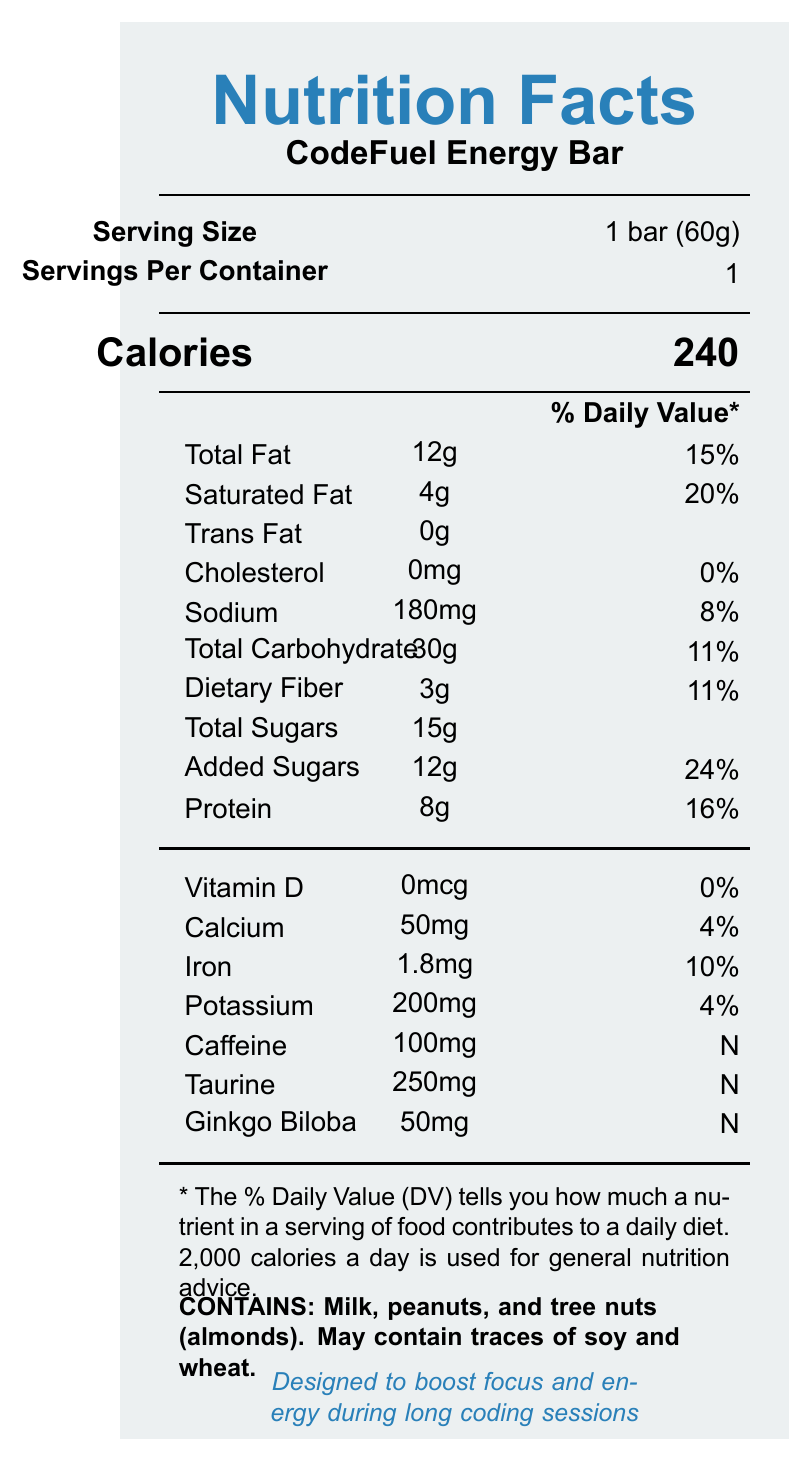What is the serving size of the CodeFuel Energy Bar? The serving size is listed in the Serving Info section and states "1 bar (60g)".
Answer: 1 bar (60g) How many calories are in one serving of the CodeFuel Energy Bar? The Calories section indicates that there are 240 calories per serving.
Answer: 240 What is the amount of total fat in the CodeFuel Energy Bar? The Nutrient table lists the Total Fat amount as 12g.
Answer: 12g How much protein does the CodeFuel Energy Bar contain? The Nutrient table shows that the CodeFuel Energy Bar contains 8g of protein.
Answer: 8g What is the Daily Value percentage of iron in the CodeFuel Energy Bar? The Vitamins and Minerals section lists Iron with a Daily Value of 10%.
Answer: 10% How much caffeine is in the CodeFuel Energy Bar? The Vitamins and Minerals section lists Caffeine amount as 100mg.
Answer: 100mg What allergens are present in the CodeFuel Energy Bar? The allergen information section mentions the presence of milk, peanuts, and tree nuts (almonds).
Answer: Milk, peanuts, and tree nuts (almonds) Which of the following ingredients is not in the CodeFuel Energy Bar? A. Sea salt B. Brown sugar C. Whey protein isolate The ingredient list does not include 'Brown sugar'.
Answer: B Which of the following nutrients has a 0% Daily Value in the CodeFuel Energy Bar? A. Cholesterol B. Sodium C. Protein D. Calcium The Nutrient table indicates that Cholesterol has a 0% Daily Value.
Answer: A Why is this energy bar particularly marketed to software developers? The marketing claim section states that the bar is "Designed to boost focus and energy during long coding sessions".
Answer: Designed to boost focus and energy during long coding sessions Is the CodeFuel Energy Bar suitable for children? The disclaimers section advises that it is "Not recommended for children."
Answer: No Describe the main idea of the CodeFuel Energy Bar's nutrition facts label. The main idea of the document is to present the nutritional content and health information for the CodeFuel Energy Bar, targeted at software developers seeking to boost focus and energy during long coding sessions.
Answer: The label provides detailed nutritional information about the CodeFuel Energy Bar, specifically designed for software developers. It includes the serving size, calorie count, and comprehensive breakdown of fats, carbohydrates, protein, vitamins, minerals, and special ingredients like caffeine, taurine, and ginkgo biloba. Additionally, it includes allergen information, disclaimers, and marketing claims emphasizing energy and focus enhancement. What is the exact address of TechNourish Labs? The provided document information does not include the manufacturer’s address.
Answer: Not enough information 